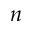<formula> <loc_0><loc_0><loc_500><loc_500>n</formula> 